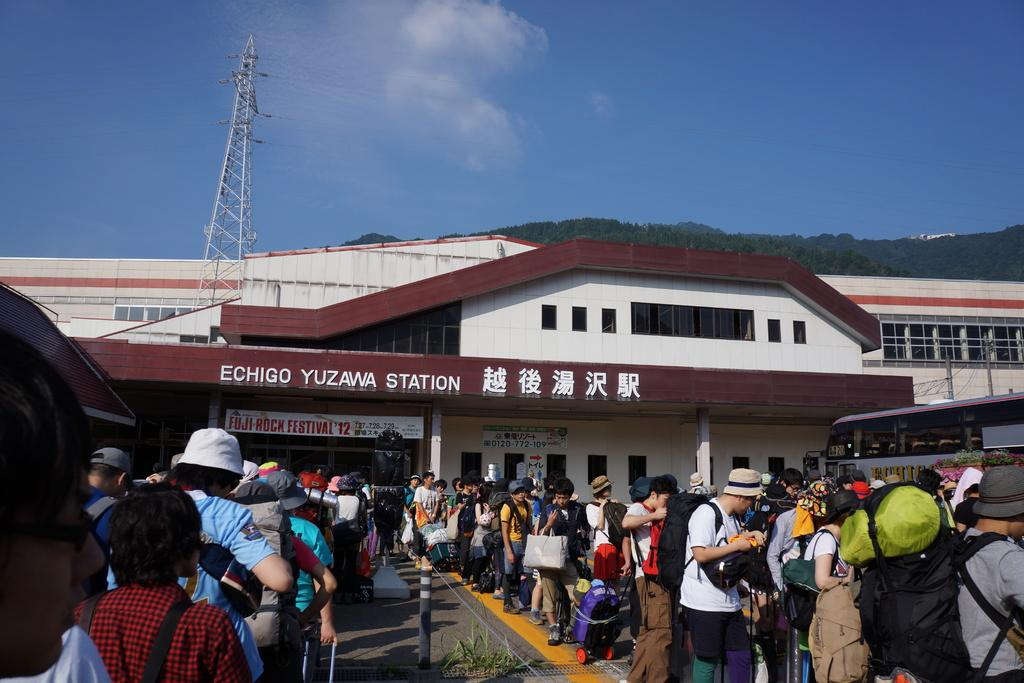What can be seen on the road in the image? There are persons on the road in the image. What mode of transportation is present in the image? There is a bus in the image. What items are being carried by the persons on the road? Briefcases and bags are visible in the image. What type of signage is present in the image? Boards are in the image. What structures are supporting the boards? Poles are present in the image. What type of building is visible in the image? There is a building in the image. What type of vegetation is visible in the image? Trees are visible in the image. What is visible in the background of the image? The sky is visible in the background of the image. What type of lock is holding the word "judge" in the image? There is no lock or word "judge" present in the image. 